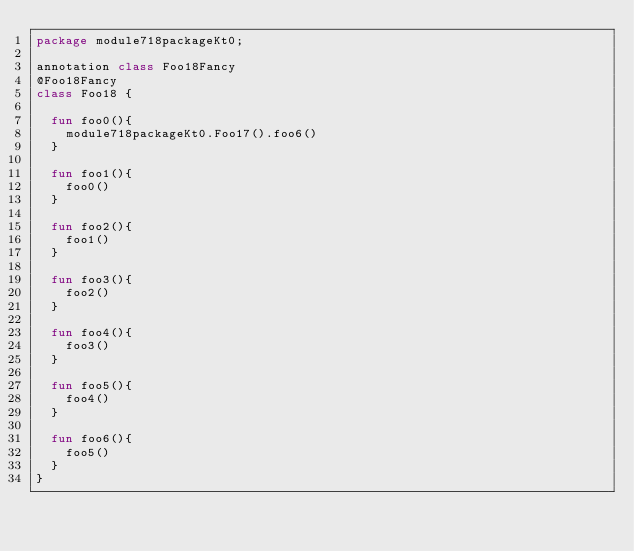<code> <loc_0><loc_0><loc_500><loc_500><_Kotlin_>package module718packageKt0;

annotation class Foo18Fancy
@Foo18Fancy
class Foo18 {

  fun foo0(){
    module718packageKt0.Foo17().foo6()
  }

  fun foo1(){
    foo0()
  }

  fun foo2(){
    foo1()
  }

  fun foo3(){
    foo2()
  }

  fun foo4(){
    foo3()
  }

  fun foo5(){
    foo4()
  }

  fun foo6(){
    foo5()
  }
}</code> 